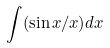Convert formula to latex. <formula><loc_0><loc_0><loc_500><loc_500>\int ( \sin x / x ) d x</formula> 